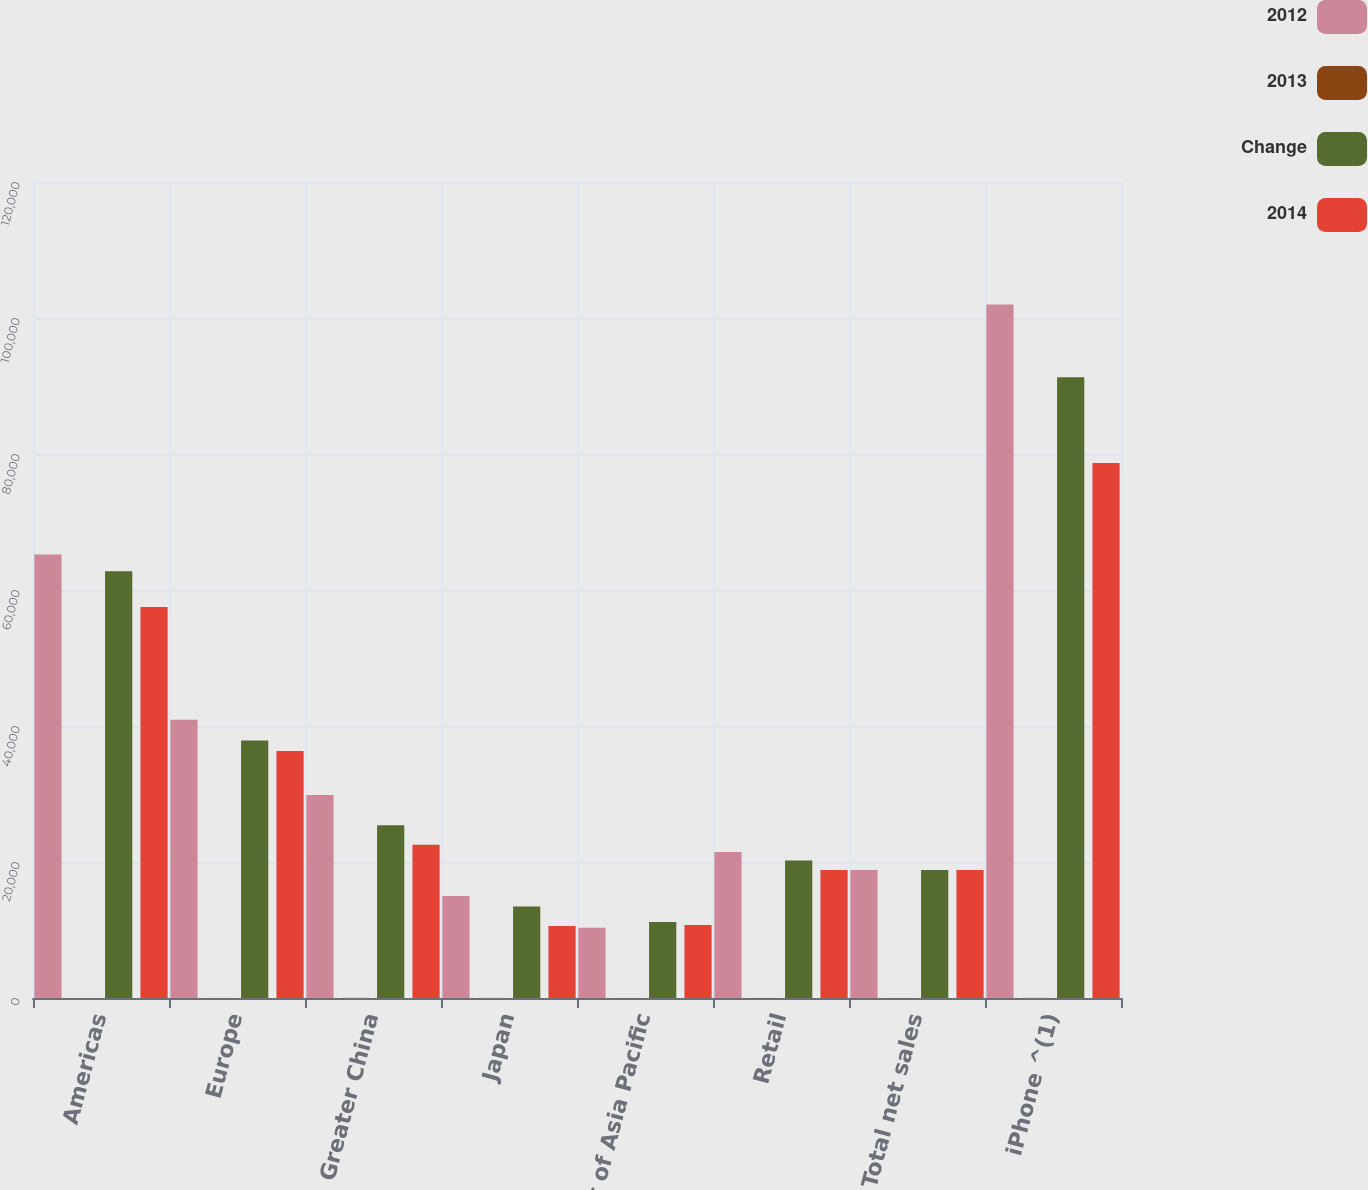Convert chart to OTSL. <chart><loc_0><loc_0><loc_500><loc_500><stacked_bar_chart><ecel><fcel>Americas<fcel>Europe<fcel>Greater China<fcel>Japan<fcel>Rest of Asia Pacific<fcel>Retail<fcel>Total net sales<fcel>iPhone ^(1)<nl><fcel>2012<fcel>65232<fcel>40929<fcel>29846<fcel>14982<fcel>10344<fcel>21462<fcel>18828<fcel>101991<nl><fcel>2013<fcel>4<fcel>8<fcel>17<fcel>11<fcel>7<fcel>6<fcel>7<fcel>12<nl><fcel>Change<fcel>62739<fcel>37883<fcel>25417<fcel>13462<fcel>11181<fcel>20228<fcel>18828<fcel>91279<nl><fcel>2014<fcel>57512<fcel>36323<fcel>22533<fcel>10571<fcel>10741<fcel>18828<fcel>18828<fcel>78692<nl></chart> 